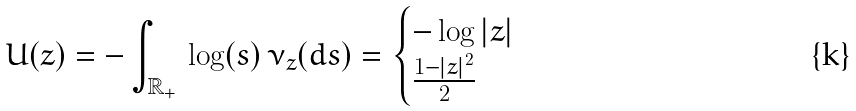<formula> <loc_0><loc_0><loc_500><loc_500>U ( z ) = - \int _ { \mathbb { R } _ { + } } \, \log ( s ) \, \nu _ { z } ( d s ) = \begin{cases} - \log | z | & \\ \frac { 1 - | z | ^ { 2 } } { 2 } & \end{cases}</formula> 